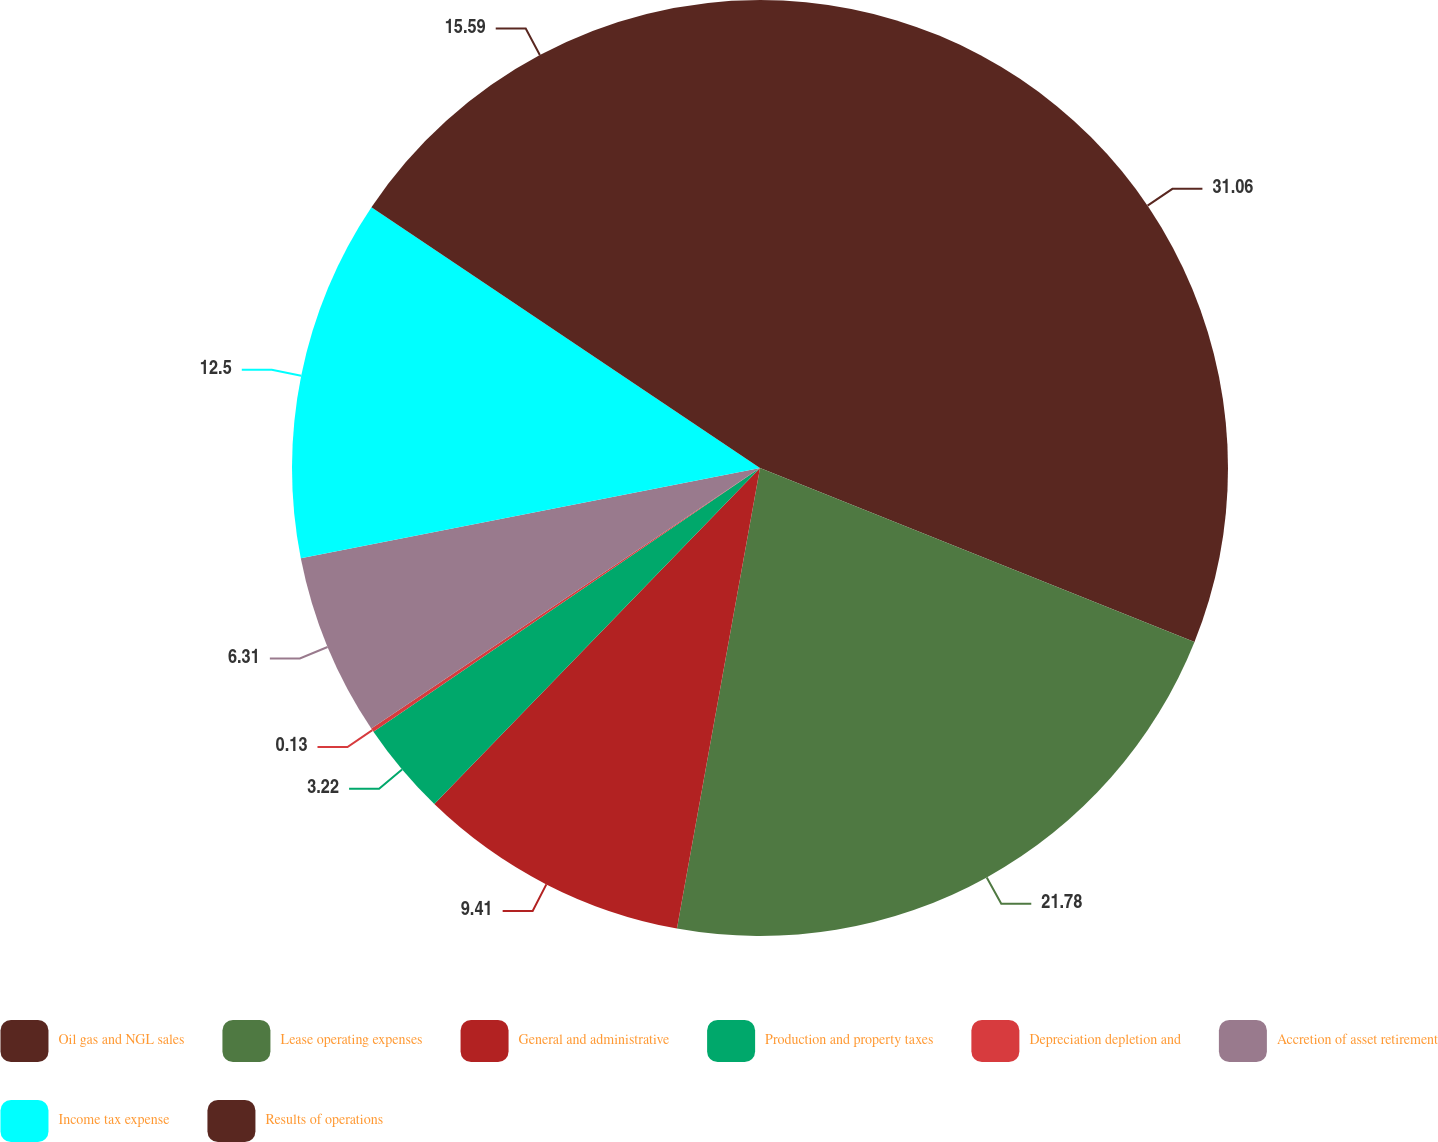<chart> <loc_0><loc_0><loc_500><loc_500><pie_chart><fcel>Oil gas and NGL sales<fcel>Lease operating expenses<fcel>General and administrative<fcel>Production and property taxes<fcel>Depreciation depletion and<fcel>Accretion of asset retirement<fcel>Income tax expense<fcel>Results of operations<nl><fcel>31.06%<fcel>21.78%<fcel>9.41%<fcel>3.22%<fcel>0.13%<fcel>6.31%<fcel>12.5%<fcel>15.59%<nl></chart> 